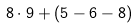Convert formula to latex. <formula><loc_0><loc_0><loc_500><loc_500>8 \cdot 9 + ( 5 - 6 - 8 )</formula> 